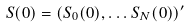Convert formula to latex. <formula><loc_0><loc_0><loc_500><loc_500>S ( 0 ) = ( S _ { 0 } ( 0 ) , \dots S _ { N } ( 0 ) ) ^ { \prime }</formula> 